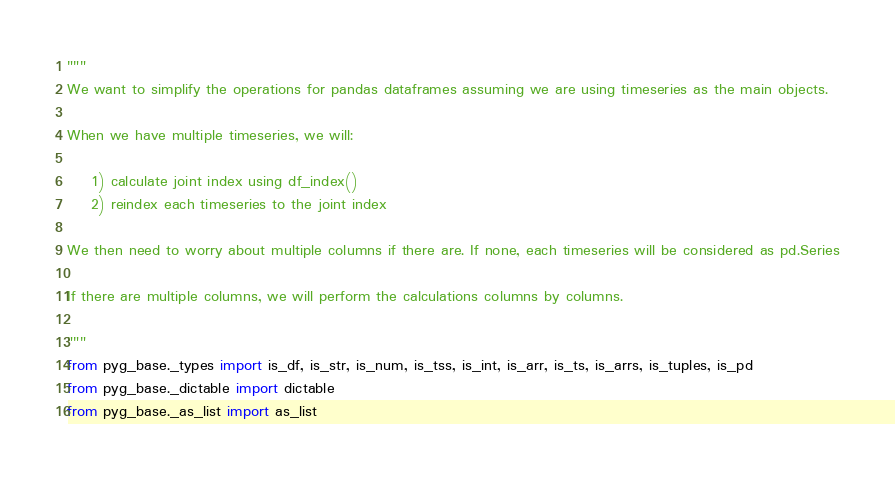Convert code to text. <code><loc_0><loc_0><loc_500><loc_500><_Python_>"""
We want to simplify the operations for pandas dataframes assuming we are using timeseries as the main objects.

When we have multiple timeseries, we will:
    
    1) calculate joint index using df_index()
    2) reindex each timeseries to the joint index
    
We then need to worry about multiple columns if there are. If none, each timeseries will be considered as pd.Series

If there are multiple columns, we will perform the calculations columns by columns. 

"""
from pyg_base._types import is_df, is_str, is_num, is_tss, is_int, is_arr, is_ts, is_arrs, is_tuples, is_pd
from pyg_base._dictable import dictable
from pyg_base._as_list import as_list</code> 